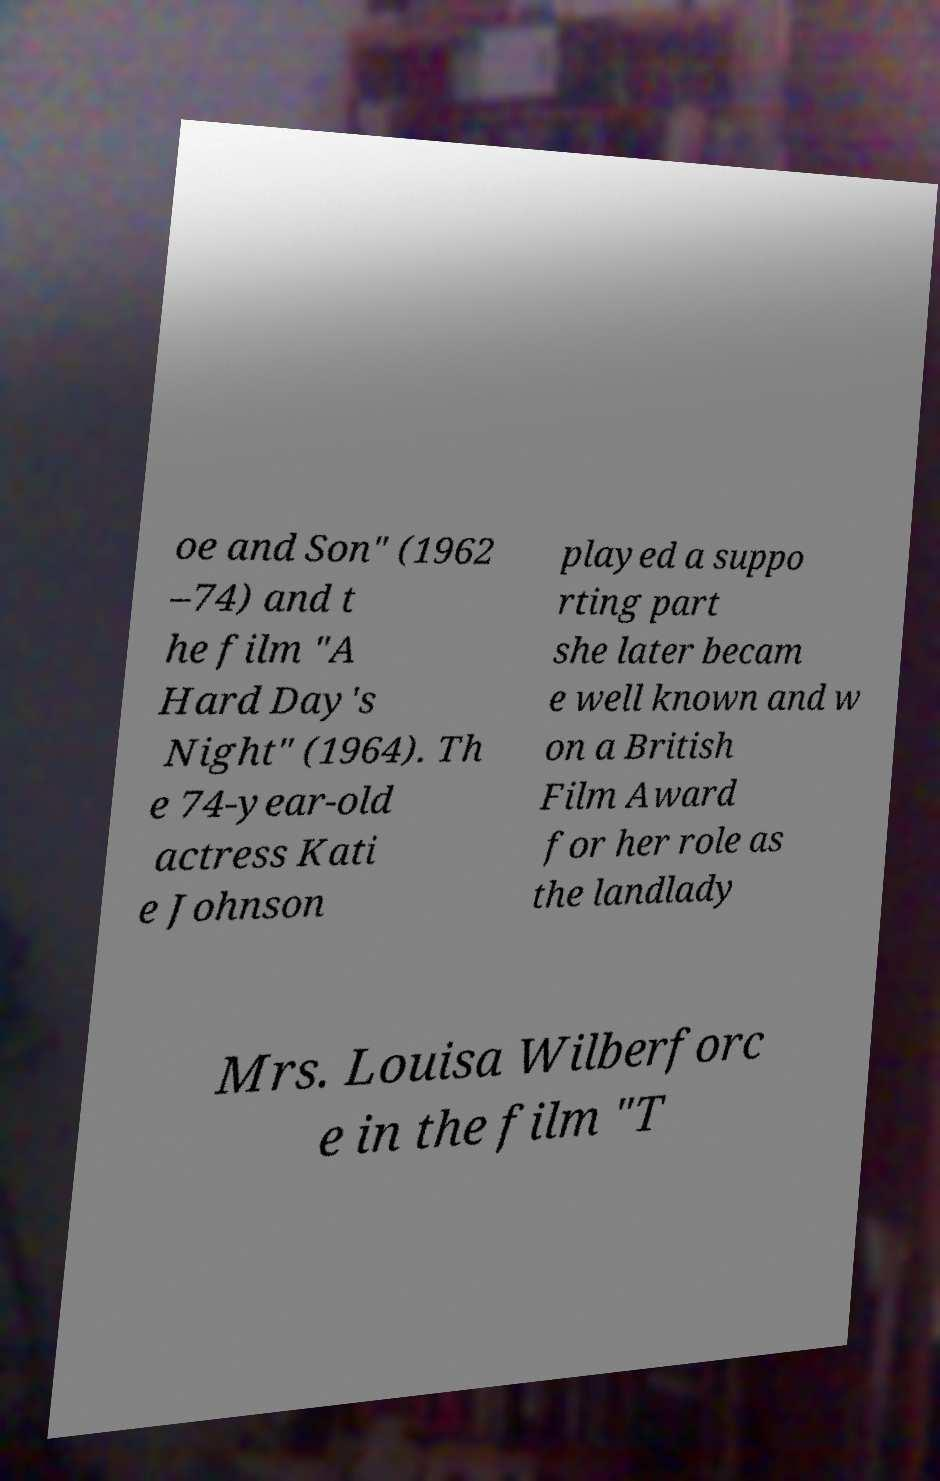For documentation purposes, I need the text within this image transcribed. Could you provide that? oe and Son" (1962 –74) and t he film "A Hard Day's Night" (1964). Th e 74-year-old actress Kati e Johnson played a suppo rting part she later becam e well known and w on a British Film Award for her role as the landlady Mrs. Louisa Wilberforc e in the film "T 